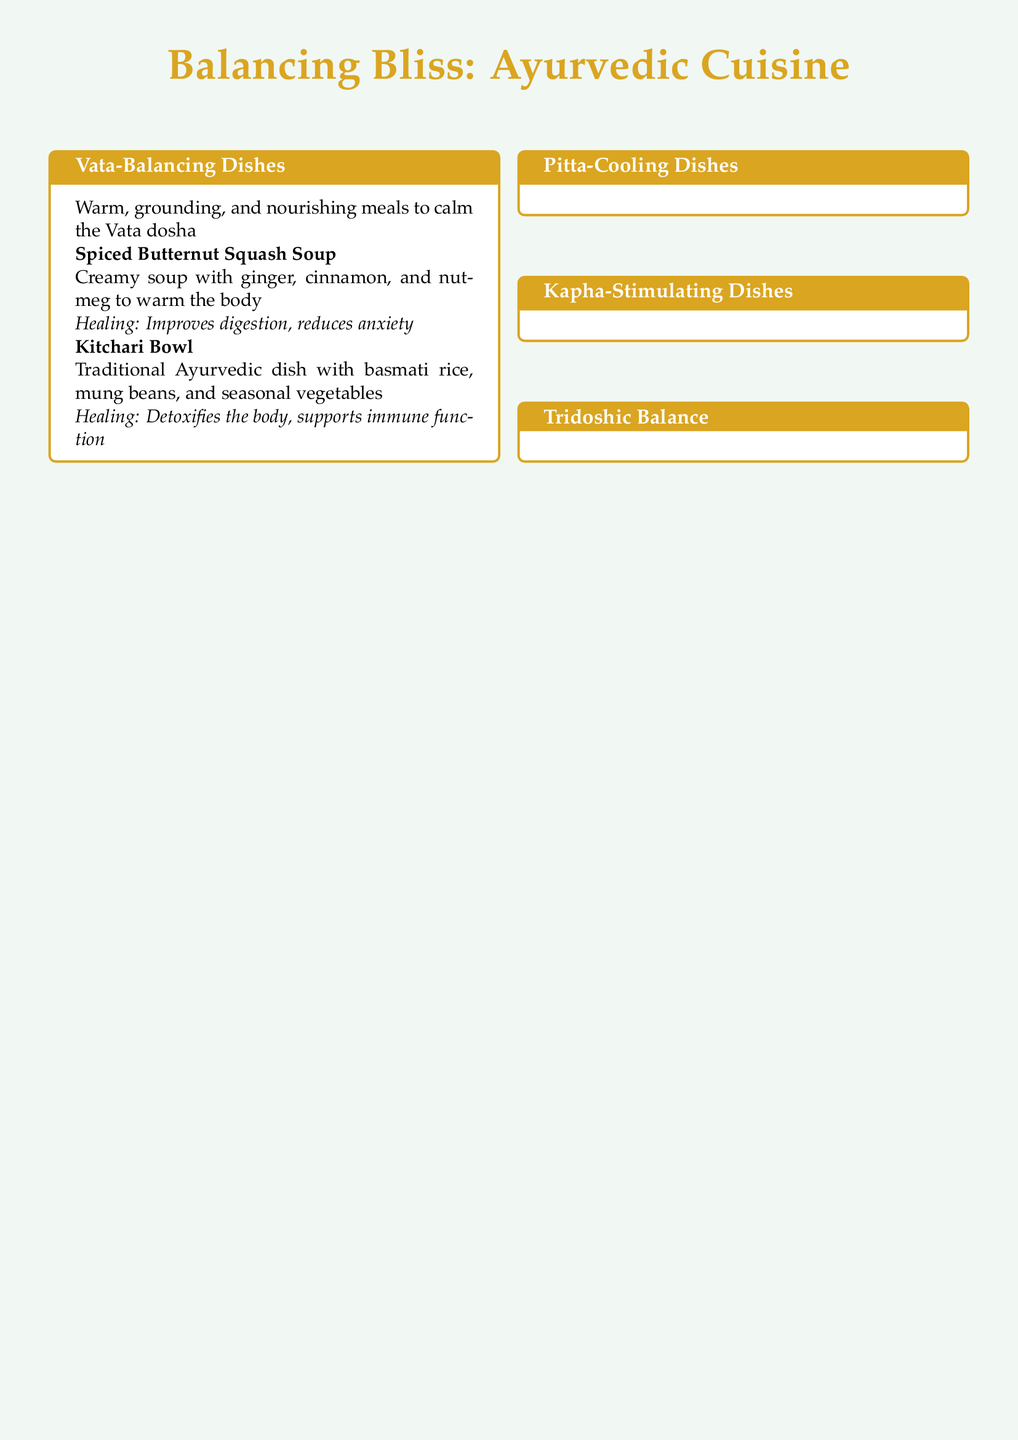What is the title of the menu? The title at the top of the document is "Balancing Bliss: Ayurvedic Cuisine."
Answer: Balancing Bliss: Ayurvedic Cuisine How many categories of dishes are there? The document lists four categories of dishes: Vata-Balancing, Pitta-Cooling, Kapha-Stimulating, and Tridoshic Balance.
Answer: Four What dish is included in the Vata-Balancing category? One of the dishes listed under the Vata-Balancing category is "Spiced Butternut Squash Soup."
Answer: Spiced Butternut Squash Soup What is a healing property of the Ginger Lemon Tea? Ginger Lemon Tea is noted for boosting metabolism and improving circulation.
Answer: Boosts metabolism, improves circulation Which dish is described as mild and anti-inflammatory? The "Coconut Curry with Vegetables" is described as a mild dish with anti-inflammatory properties.
Answer: Coconut Curry with Vegetables What type of dishes promote overall balance? The document states that "Tridoshic Balance" dishes are suitable for all doshas, promoting overall balance.
Answer: Tridoshic Balance What ingredient is common in the Golden Milk? The Golden Milk contains turmeric, which is its primary ingredient.
Answer: Turmeric Which dish is noted for supporting weight management? The "Quinoa Tabbouleh Salad" is mentioned as supporting weight management.
Answer: Quinoa Tabbouleh Salad 